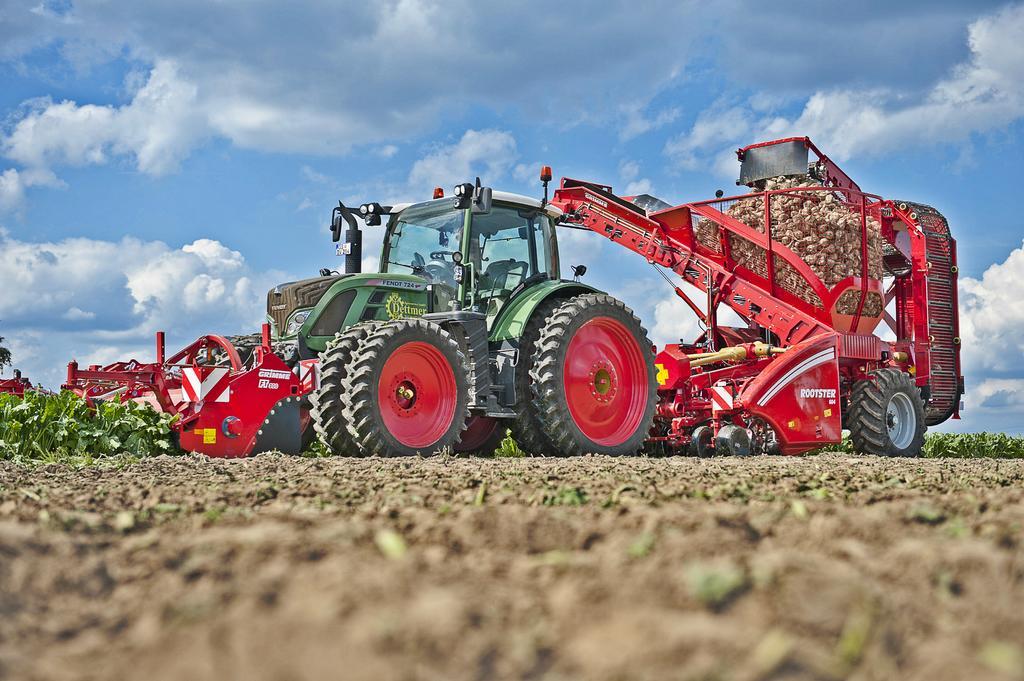How would you summarize this image in a sentence or two? In this picture there is a tractor at the top side of the image. 